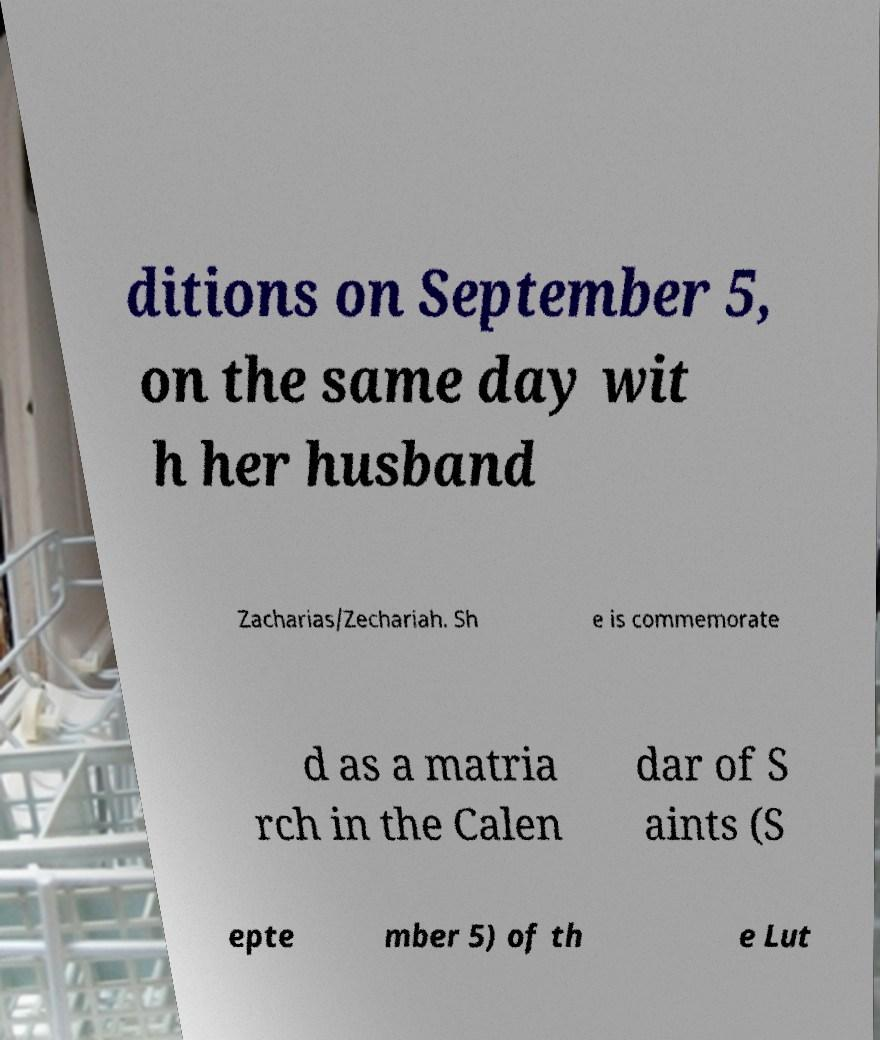Could you extract and type out the text from this image? ditions on September 5, on the same day wit h her husband Zacharias/Zechariah. Sh e is commemorate d as a matria rch in the Calen dar of S aints (S epte mber 5) of th e Lut 